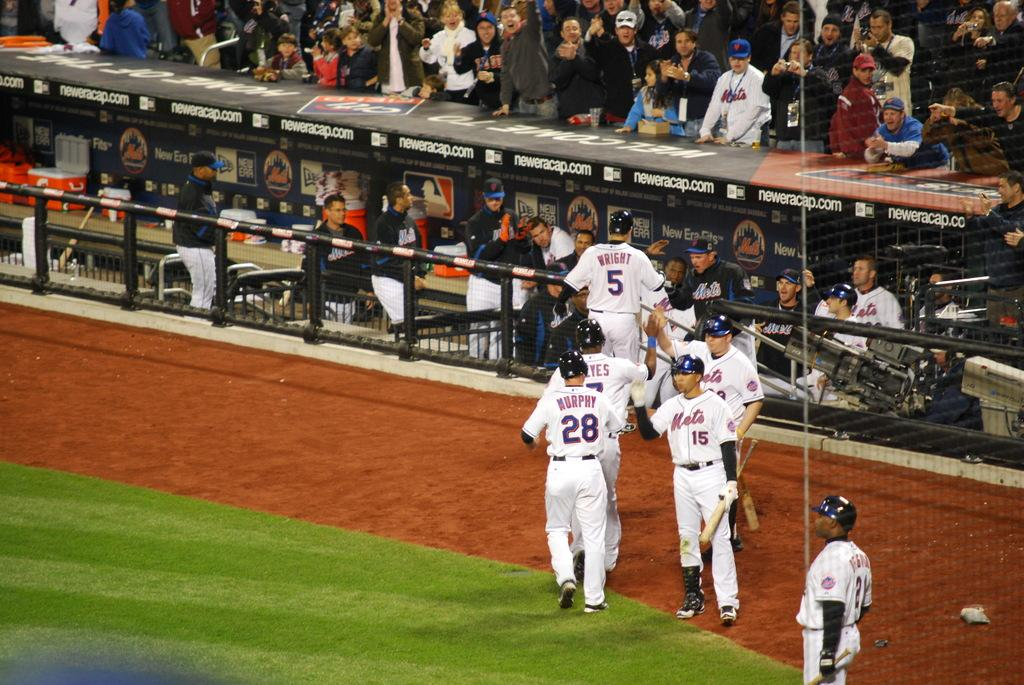Provide a one-sentence caption for the provided image. Players from the Mets baseball time lined up in opposite directions giving each other high fives as they walk to the dugout. 